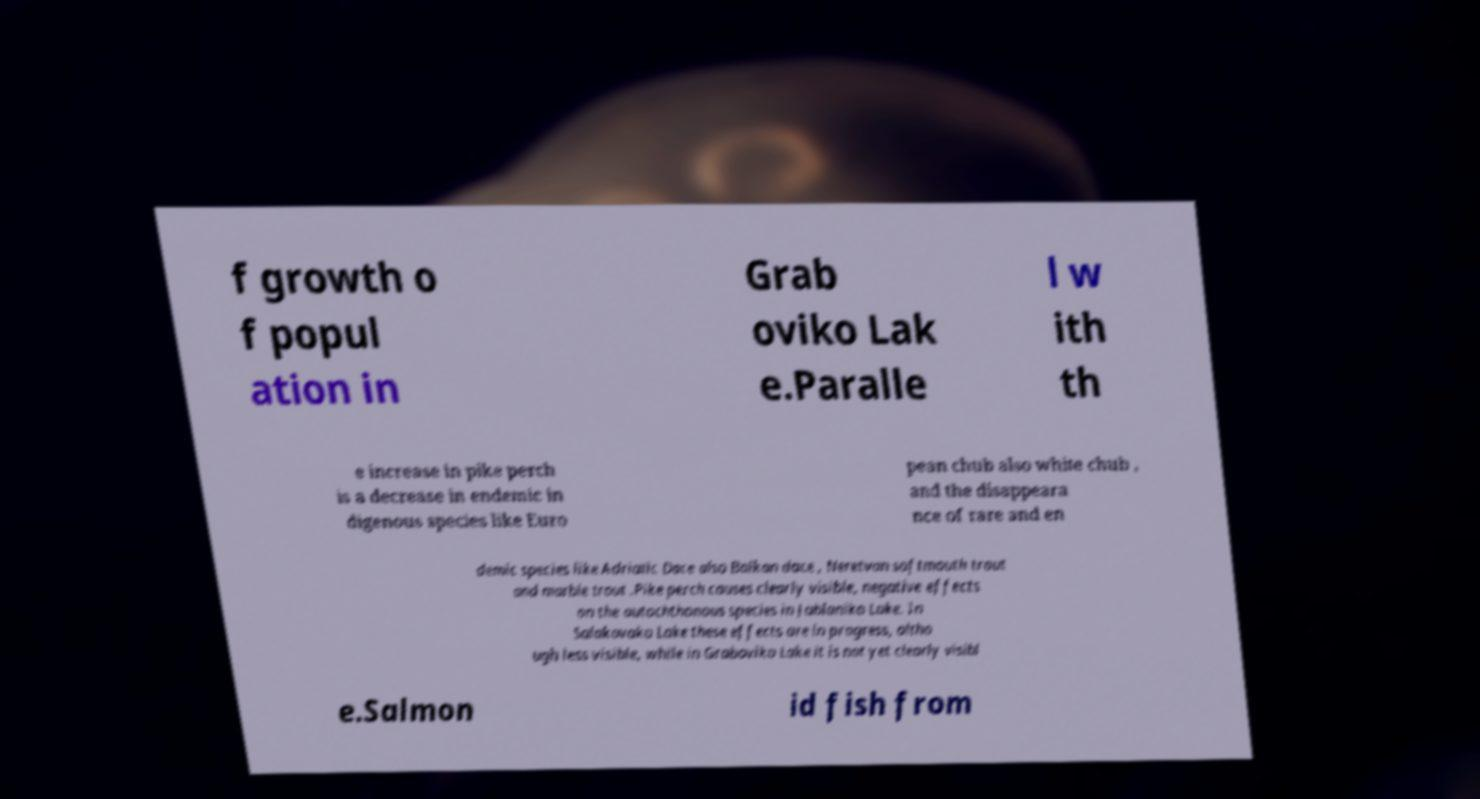Please identify and transcribe the text found in this image. f growth o f popul ation in Grab oviko Lak e.Paralle l w ith th e increase in pike perch is a decrease in endemic in digenous species like Euro pean chub also white chub , and the disappeara nce of rare and en demic species like Adriatic Dace also Balkan dace , Neretvan softmouth trout and marble trout .Pike perch causes clearly visible, negative effects on the autochthonous species in Jablaniko Lake. In Salakovako Lake these effects are in progress, altho ugh less visible, while in Graboviko Lake it is not yet clearly visibl e.Salmon id fish from 